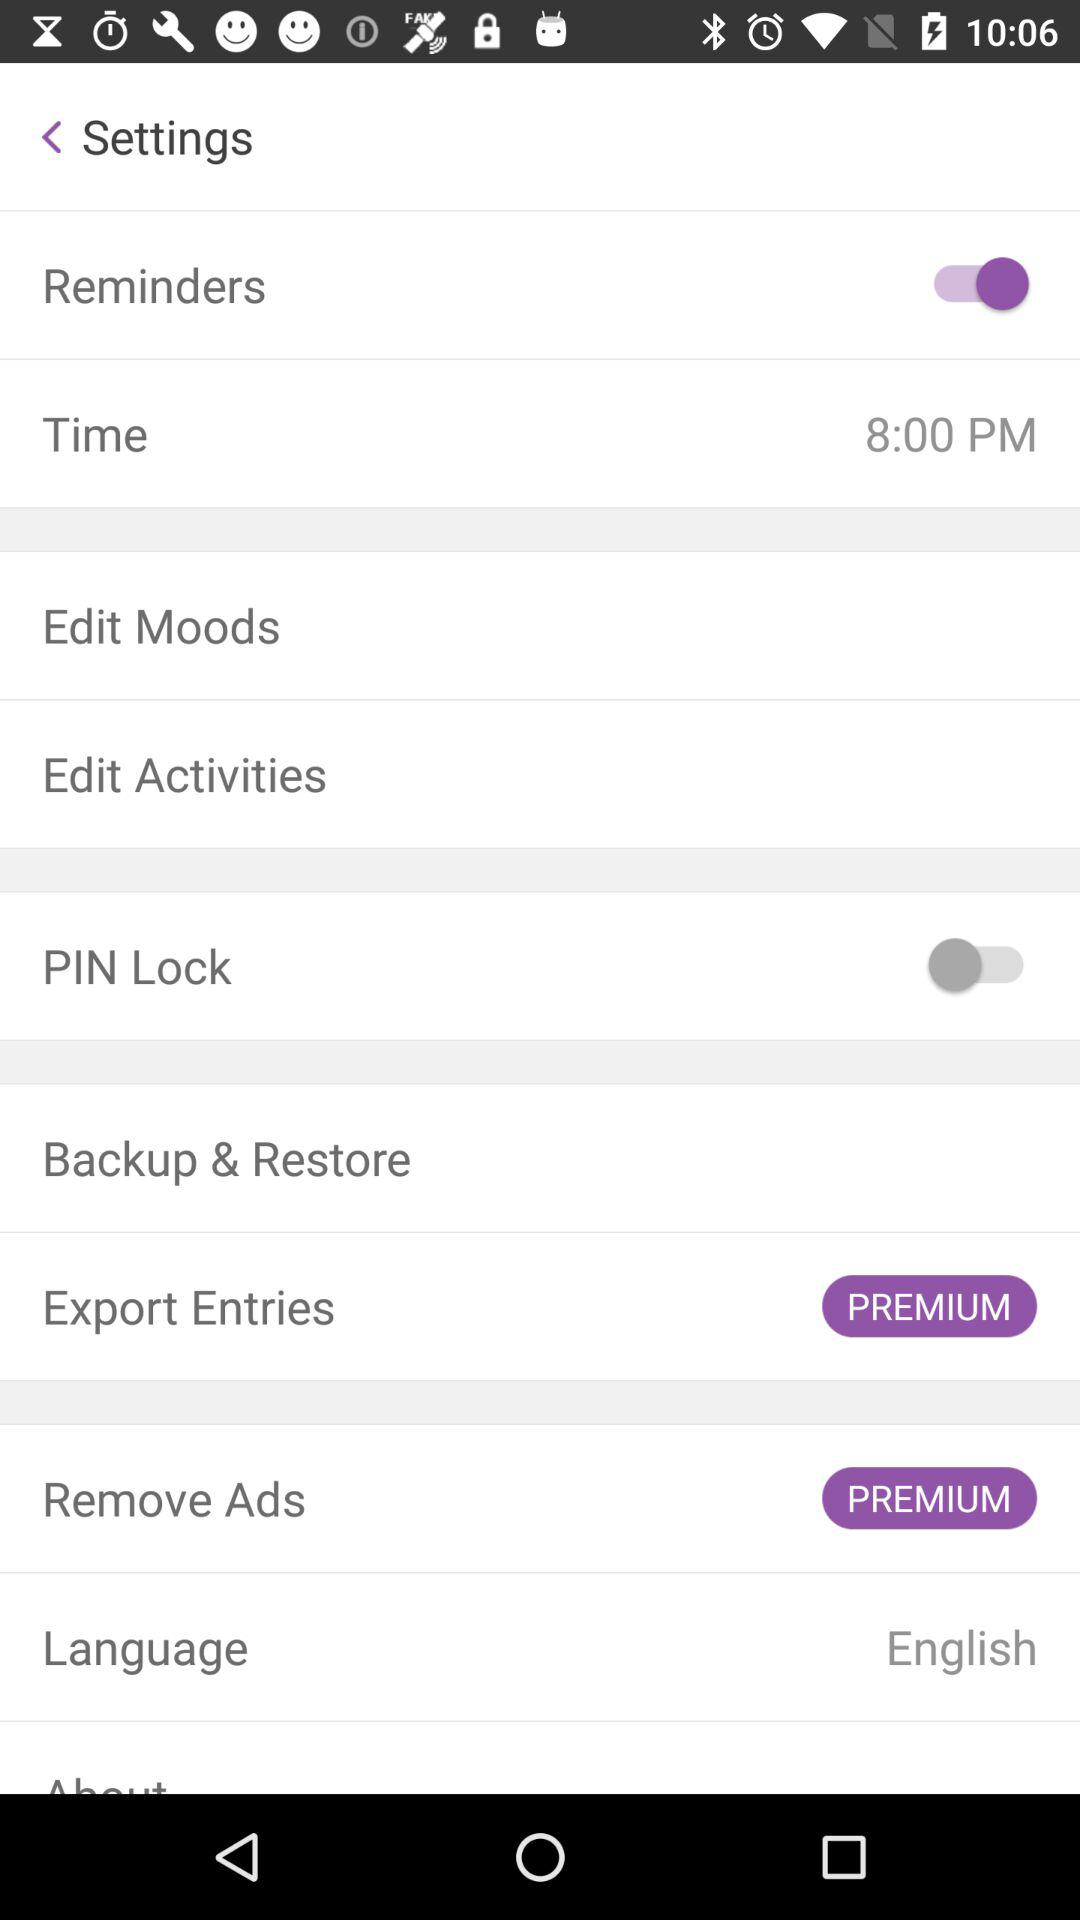What is the status of "PIN Lock"? The status is "off". 